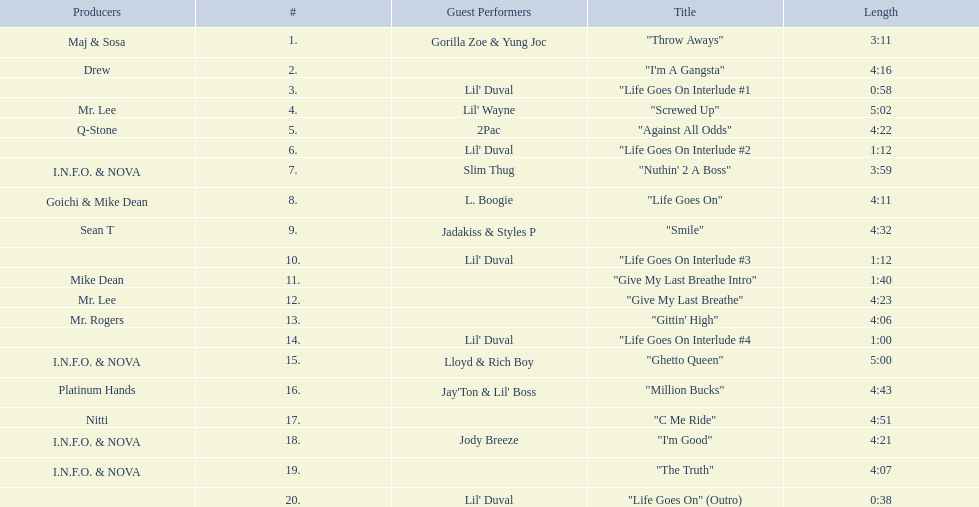What tracks appear on the album life goes on (trae album)? "Throw Aways", "I'm A Gangsta", "Life Goes On Interlude #1, "Screwed Up", "Against All Odds", "Life Goes On Interlude #2, "Nuthin' 2 A Boss", "Life Goes On", "Smile", "Life Goes On Interlude #3, "Give My Last Breathe Intro", "Give My Last Breathe", "Gittin' High", "Life Goes On Interlude #4, "Ghetto Queen", "Million Bucks", "C Me Ride", "I'm Good", "The Truth", "Life Goes On" (Outro). Parse the full table. {'header': ['Producers', '#', 'Guest Performers', 'Title', 'Length'], 'rows': [['Maj & Sosa', '1.', 'Gorilla Zoe & Yung Joc', '"Throw Aways"', '3:11'], ['Drew', '2.', '', '"I\'m A Gangsta"', '4:16'], ['', '3.', "Lil' Duval", '"Life Goes On Interlude #1', '0:58'], ['Mr. Lee', '4.', "Lil' Wayne", '"Screwed Up"', '5:02'], ['Q-Stone', '5.', '2Pac', '"Against All Odds"', '4:22'], ['', '6.', "Lil' Duval", '"Life Goes On Interlude #2', '1:12'], ['I.N.F.O. & NOVA', '7.', 'Slim Thug', '"Nuthin\' 2 A Boss"', '3:59'], ['Goichi & Mike Dean', '8.', 'L. Boogie', '"Life Goes On"', '4:11'], ['Sean T', '9.', 'Jadakiss & Styles P', '"Smile"', '4:32'], ['', '10.', "Lil' Duval", '"Life Goes On Interlude #3', '1:12'], ['Mike Dean', '11.', '', '"Give My Last Breathe Intro"', '1:40'], ['Mr. Lee', '12.', '', '"Give My Last Breathe"', '4:23'], ['Mr. Rogers', '13.', '', '"Gittin\' High"', '4:06'], ['', '14.', "Lil' Duval", '"Life Goes On Interlude #4', '1:00'], ['I.N.F.O. & NOVA', '15.', 'Lloyd & Rich Boy', '"Ghetto Queen"', '5:00'], ['Platinum Hands', '16.', "Jay'Ton & Lil' Boss", '"Million Bucks"', '4:43'], ['Nitti', '17.', '', '"C Me Ride"', '4:51'], ['I.N.F.O. & NOVA', '18.', 'Jody Breeze', '"I\'m Good"', '4:21'], ['I.N.F.O. & NOVA', '19.', '', '"The Truth"', '4:07'], ['', '20.', "Lil' Duval", '"Life Goes On" (Outro)', '0:38']]} Which of these songs are at least 5 minutes long? "Screwed Up", "Ghetto Queen". Of these two songs over 5 minutes long, which is longer? "Screwed Up". How long is this track? 5:02. 